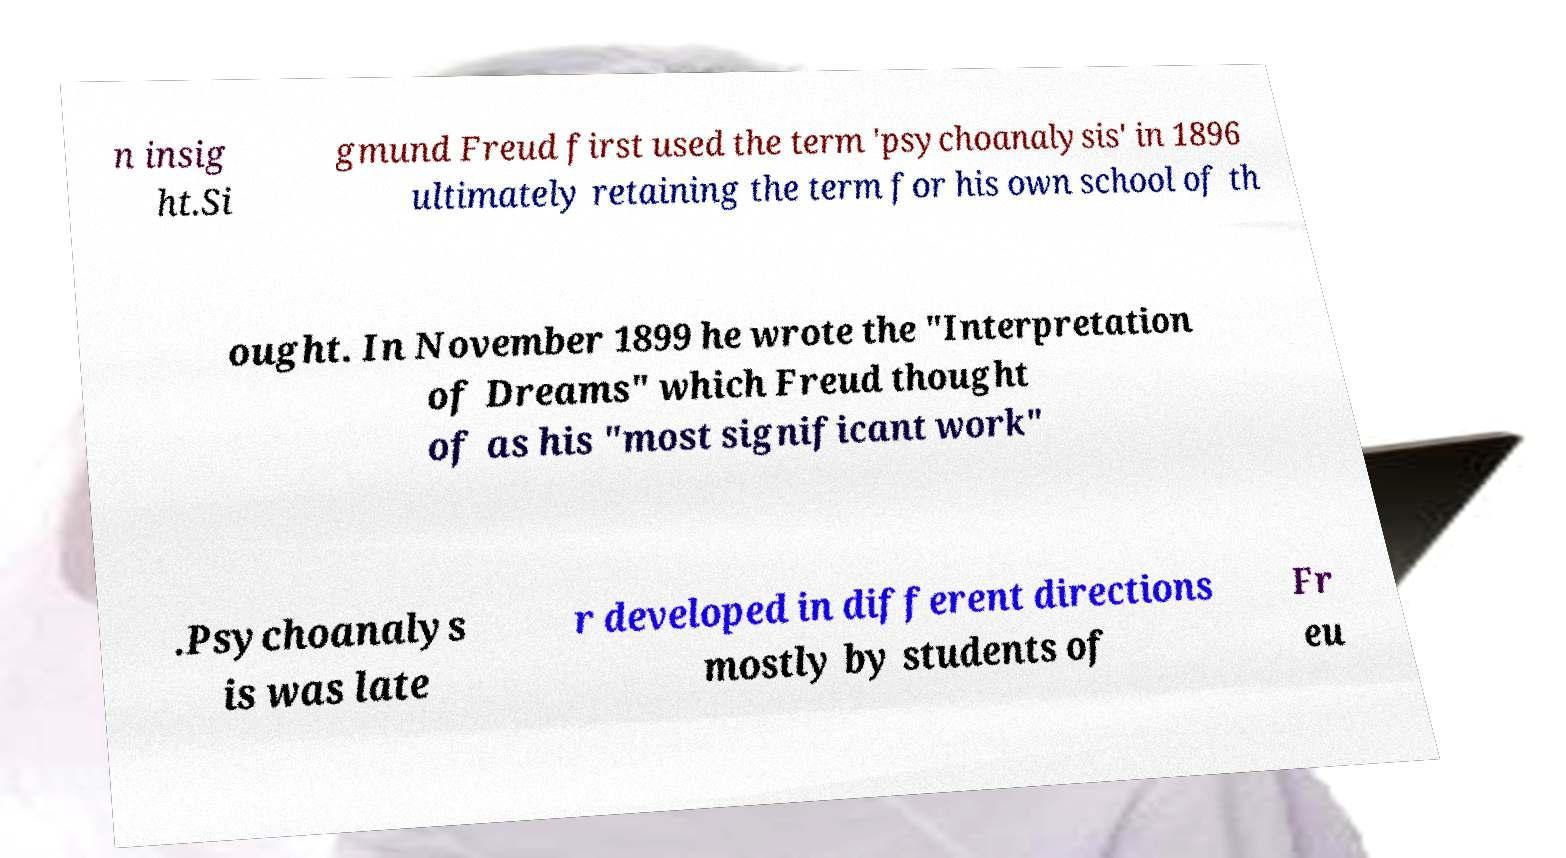Can you accurately transcribe the text from the provided image for me? n insig ht.Si gmund Freud first used the term 'psychoanalysis' in 1896 ultimately retaining the term for his own school of th ought. In November 1899 he wrote the "Interpretation of Dreams" which Freud thought of as his "most significant work" .Psychoanalys is was late r developed in different directions mostly by students of Fr eu 